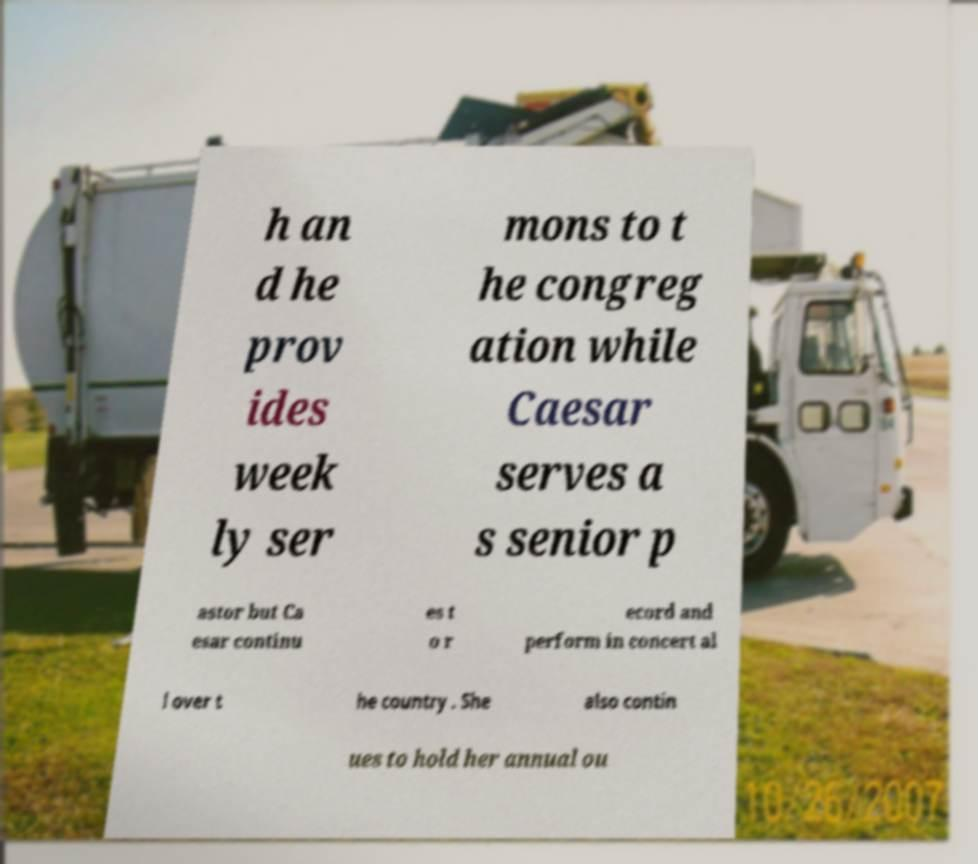What messages or text are displayed in this image? I need them in a readable, typed format. h an d he prov ides week ly ser mons to t he congreg ation while Caesar serves a s senior p astor but Ca esar continu es t o r ecord and perform in concert al l over t he country . She also contin ues to hold her annual ou 